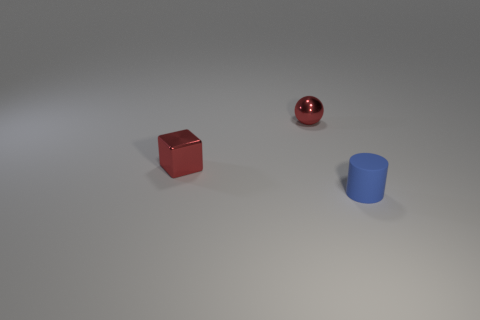Is there any other thing that is the same shape as the small rubber object?
Offer a terse response. No. Is the size of the metal object to the left of the sphere the same as the red thing right of the tiny cube?
Provide a succinct answer. Yes. What is the color of the thing to the left of the small metallic ball?
Your answer should be very brief. Red. Are there fewer red shiny balls that are behind the small metallic ball than big green metallic blocks?
Make the answer very short. No. Is the material of the small red cube the same as the cylinder?
Your answer should be compact. No. What number of things are either tiny things that are behind the small blue rubber cylinder or objects left of the small blue rubber thing?
Your response must be concise. 2. Is the number of tiny red shiny cubes less than the number of gray metal things?
Offer a very short reply. No. What number of rubber objects are small cylinders or gray cubes?
Make the answer very short. 1. Are there more small purple blocks than small red metal objects?
Keep it short and to the point. No. There is a cube that is the same color as the sphere; what size is it?
Your response must be concise. Small. 